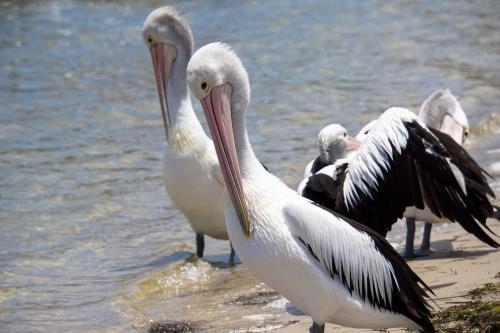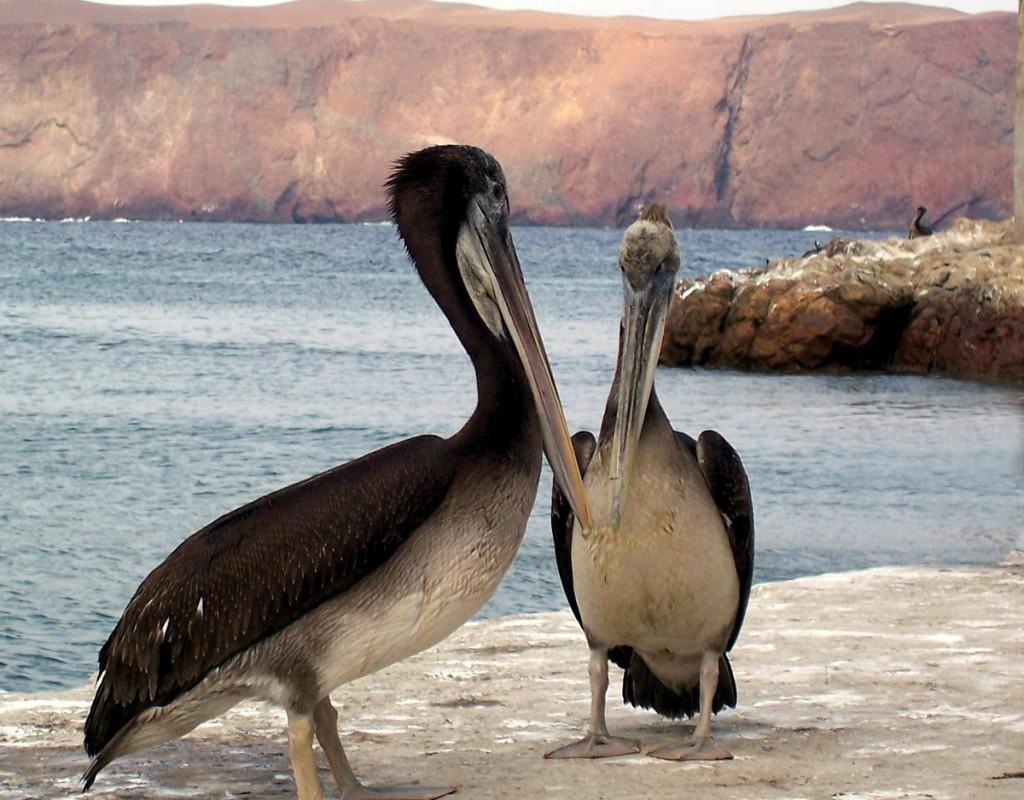The first image is the image on the left, the second image is the image on the right. Evaluate the accuracy of this statement regarding the images: "All pelicans are on the water, one image contains exactly two pelicans, and each image contains no more than three pelicans.". Is it true? Answer yes or no. No. The first image is the image on the left, the second image is the image on the right. Analyze the images presented: Is the assertion "There is no more than two birds in the left image." valid? Answer yes or no. No. 